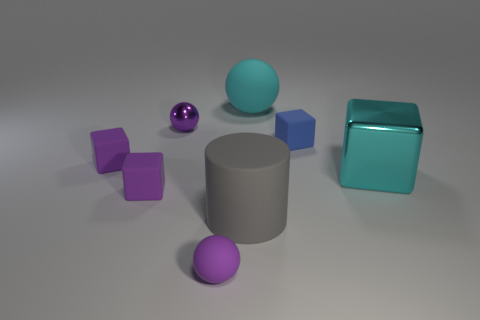The purple metallic sphere is what size?
Your answer should be very brief. Small. How big is the purple object in front of the large gray object?
Provide a short and direct response. Small. Does the cyan ball have the same size as the purple rubber ball in front of the small blue block?
Give a very brief answer. No. How many tiny matte blocks are the same color as the tiny rubber ball?
Give a very brief answer. 2. What number of tiny blue objects have the same material as the cyan ball?
Give a very brief answer. 1. Do the large cyan object that is behind the big shiny object and the large cube have the same material?
Your response must be concise. No. Are there more cyan objects that are to the left of the big cyan cube than shiny cubes in front of the big gray rubber cylinder?
Offer a terse response. Yes. There is a gray cylinder that is the same size as the cyan rubber thing; what is its material?
Make the answer very short. Rubber. What number of other objects are there of the same material as the big block?
Keep it short and to the point. 1. Do the cyan thing that is to the left of the big cyan cube and the metallic thing that is on the left side of the tiny purple rubber ball have the same shape?
Provide a succinct answer. Yes. 